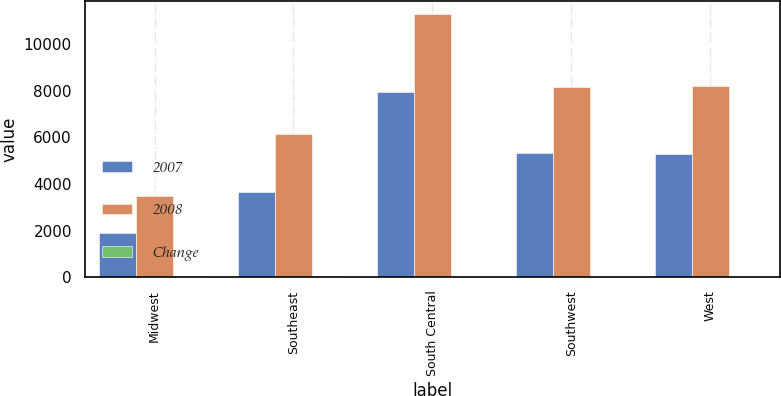Convert chart. <chart><loc_0><loc_0><loc_500><loc_500><stacked_bar_chart><ecel><fcel>Midwest<fcel>Southeast<fcel>South Central<fcel>Southwest<fcel>West<nl><fcel>2007<fcel>1905<fcel>3650<fcel>7960<fcel>5309<fcel>5263<nl><fcel>2008<fcel>3502<fcel>6156<fcel>11260<fcel>8149<fcel>8184<nl><fcel>Change<fcel>46<fcel>41<fcel>29<fcel>35<fcel>36<nl></chart> 